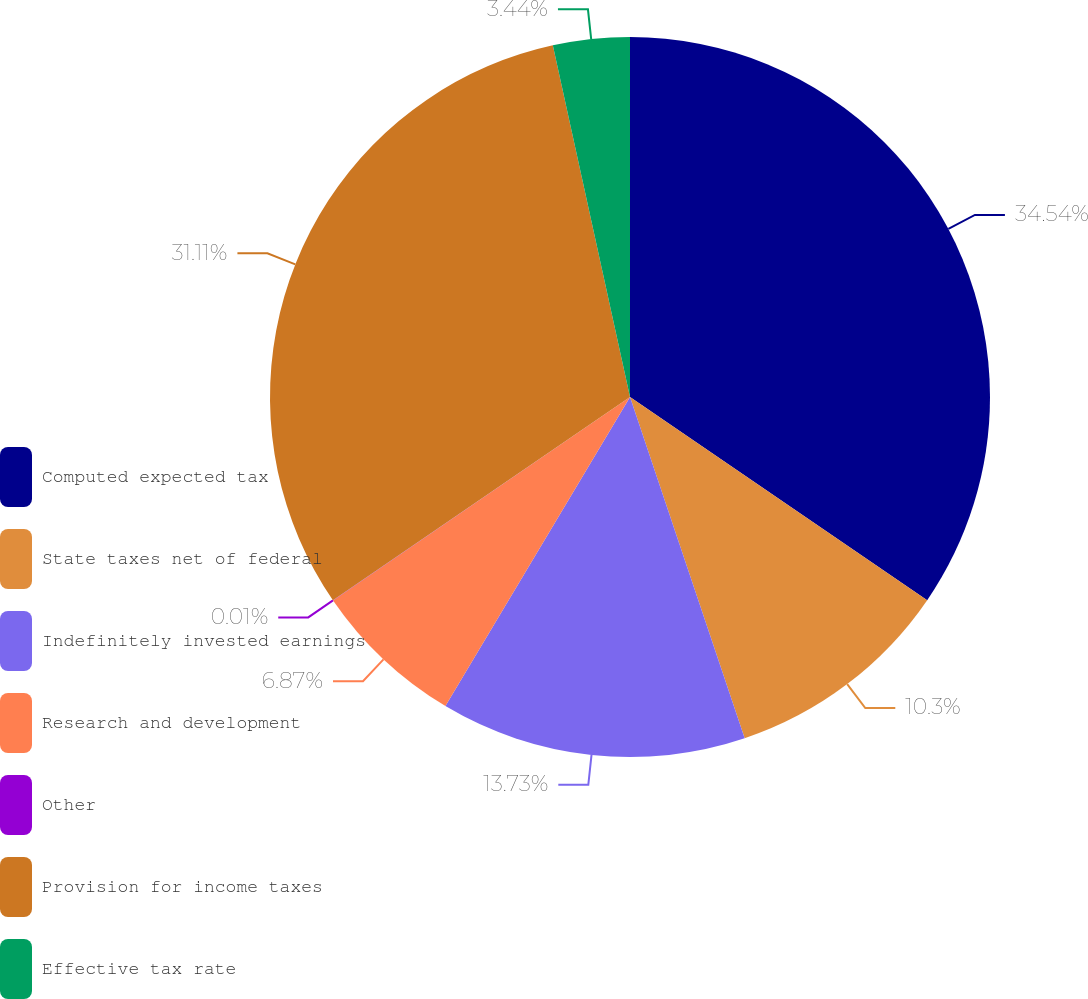Convert chart to OTSL. <chart><loc_0><loc_0><loc_500><loc_500><pie_chart><fcel>Computed expected tax<fcel>State taxes net of federal<fcel>Indefinitely invested earnings<fcel>Research and development<fcel>Other<fcel>Provision for income taxes<fcel>Effective tax rate<nl><fcel>34.55%<fcel>10.3%<fcel>13.73%<fcel>6.87%<fcel>0.01%<fcel>31.12%<fcel>3.44%<nl></chart> 